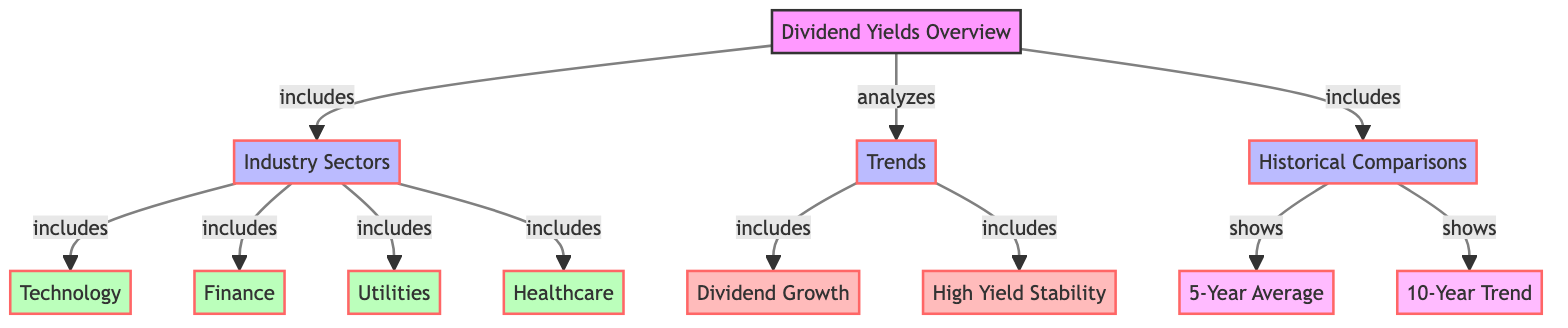What is the main focus of the diagram? The diagram mainly focuses on providing an overview of dividend yields among various industry sectors, highlighting trends and historical comparisons.
Answer: Dividend yields overview How many industry sectors are included in the diagram? By counting the nodes connected to the 'Industry Sectors' node, we find there are four sectors listed: Technology, Finance, Utilities, and Healthcare.
Answer: Four What are the two trends analyzed in the dividend yields? The trends analyzed include 'Dividend Growth' and 'High Yield Stability' as indicated in the 'Trends' node that connects to these two concepts.
Answer: Dividend Growth and High Yield Stability What does the 'Historical Comparisons' node show? The 'Historical Comparisons' node shows both the '5-Year Average' and the '10-Year Trend', which are the specific comparisons addressed in that section of the diagram.
Answer: 5-Year Average and 10-Year Trend Which industry sector is notably absent from the diagram? Analyzing the nodes, sectors like Consumer Goods, Energy, or any sectors not listed, such as real estate, are absent from the illustration showing only Technology, Finance, Utilities, and Healthcare.
Answer: Absent sectors include Consumer Goods and Energy What connects the 'Dividends Yields Overview' node to 'Industry Sectors'? The connection indicates that the overview is inclusive of these industry sectors, implying that the dividend yields discussed in the overview pertain to these specific sectors.
Answer: Includes What does the diagram illustrate about trends in dividend yields? The diagram illustrates that trends focus on two main aspects: dividend growth and the stability of high yields, which are critical in analyzing the dividends over time.
Answer: Trends include dividend growth and high yield stability How do historical comparisons contribute to understanding dividend yields? Historical comparisons provide context and benchmarks for evaluating the current state of dividend yields by presenting both a 5-year average and a 10-year trend, offering insights into past performance and future expectations.
Answer: 5-Year Average and 10-Year Trend 